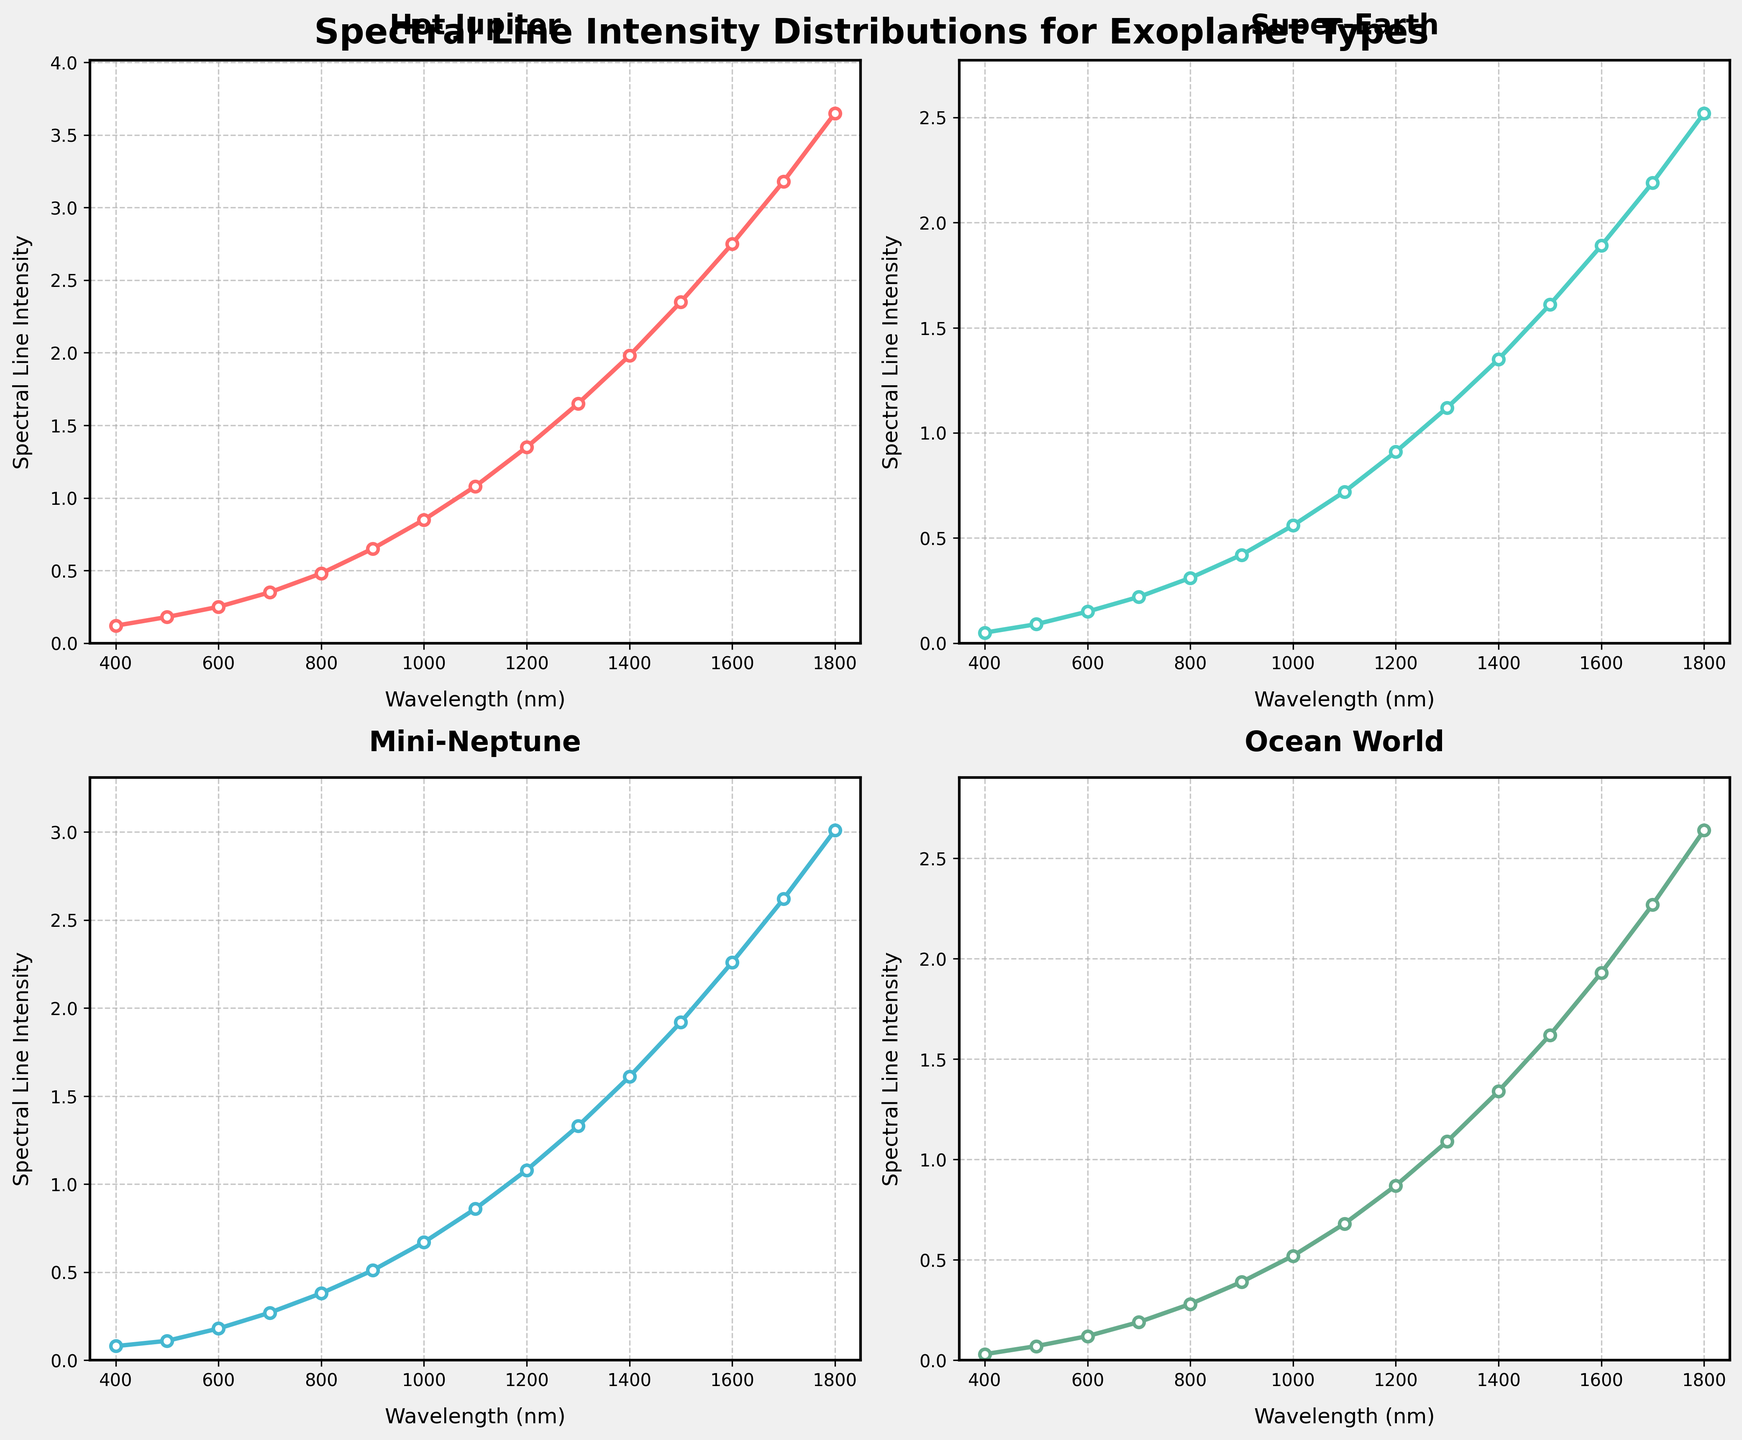What is the title of the figure? The title is usually displayed at the top of the figure. By looking at the figure's top, the title "Spectral Line Intensity Distributions for Exoplanet Types" can be seen.
Answer: Spectral Line Intensity Distributions for Exoplanet Types Which exoplanet type shows the highest spectral line intensity at a wavelength of 1000 nm? The subplot for each exoplanet type has a line chart of spectral line intensity over different wavelengths. At the wavelength of 1000 nm, the highest point amongst all four subplots is the Hot Jupiter.
Answer: Hot Jupiter Between the Super-Earth and Ocean World, which exoplanet type has a higher spectral line intensity at 1500 nm? To compare the spectral line intensities at 1500 nm, check the values on the plots for Super-Earth and Ocean World at that wavelength. Super-Earth is 1.61 and Ocean World is 1.62. Ocean World has a higher intensity.
Answer: Ocean World What is the spectral line intensity at 800 nm for the Mini-Neptune? Look at the Mini-Neptune subplot and find the y-value that corresponds to the x-value of 800 nm. The spectral line intensity at this point is 0.38.
Answer: 0.38 At what wavelength does the Hot Jupiter reach an intensity of approximately 1.65? In the Hot Jupiter subplot, check the point on the x-axis where the line reaches a y-value of approximately 1.65. It occurs at a wavelength of 1300 nm.
Answer: 1300 nm How does the spectral line intensity of Ocean World change from 400 nm to 1800 nm? Observe the Ocean World subplot. Initially, at 400 nm, the intensity is 0.03, and it steadily increases to 2.64 at 1800 nm. This indicates a consistent upward trend.
Answer: It steadily increases What is the difference in spectral line intensity between Hot Jupiter and Mini-Neptune at 900 nm? Find the values for spectral line intensities of Hot Jupiter and Mini-Neptune at 900 nm. Hot Jupiter's intensity is 0.65, and Mini-Neptune's is 0.51. The difference is 0.65 - 0.51 = 0.14.
Answer: 0.14 Which exoplanet type has the steepest increase in spectral line intensity between 1100 nm and 1500 nm? Check the subplots and compare how steep the lines rise between 1100 nm and 1500 nm for each exoplanet type. Hot Jupiter shows the steepest increase from 1.08 to 2.35, a difference of 1.27.
Answer: Hot Jupiter What can you infer about the trend of spectral line intensity for Super-Earth above 1300 nm? Observing the Super-Earth subplot above 1300 nm, the intensity continues to rise as the wavelength increases, indicating an upward trend beyond this point.
Answer: Upward trend 